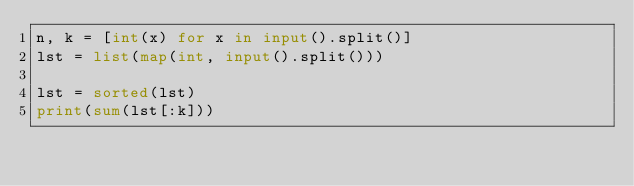Convert code to text. <code><loc_0><loc_0><loc_500><loc_500><_Python_>n, k = [int(x) for x in input().split()]
lst = list(map(int, input().split()))

lst = sorted(lst)
print(sum(lst[:k]))
</code> 